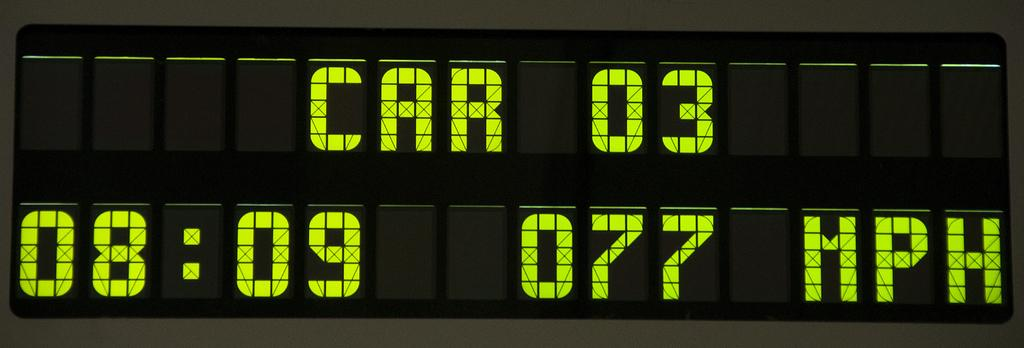<image>
Render a clear and concise summary of the photo. A lighted sign show statistics for Car 03. 